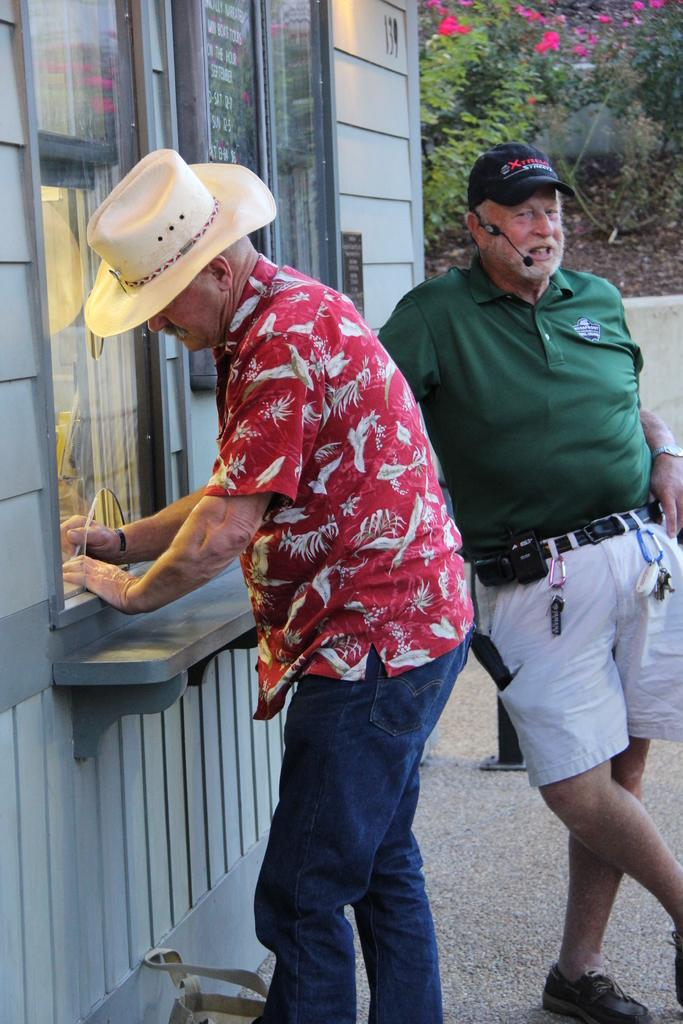How many people are present in the image? There are two persons standing in the image. What can be seen on the left side of the image? There is a wall with glass windows on the left side of the image. What type of vegetation is visible in the background of the image? There are plants with flowers in the background of the image. What type of cart can be seen carrying mint leaves in the image? There is no cart or mint leaves present in the image. 